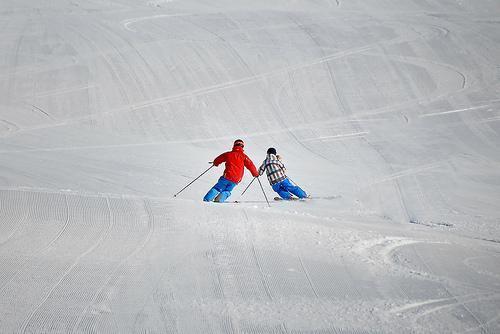How many people are in the photo?
Give a very brief answer. 2. 